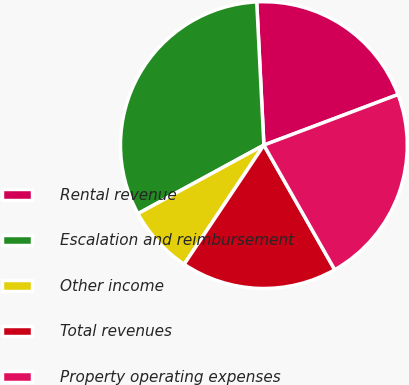Convert chart to OTSL. <chart><loc_0><loc_0><loc_500><loc_500><pie_chart><fcel>Rental revenue<fcel>Escalation and reimbursement<fcel>Other income<fcel>Total revenues<fcel>Property operating expenses<nl><fcel>20.06%<fcel>32.14%<fcel>7.68%<fcel>17.61%<fcel>22.51%<nl></chart> 